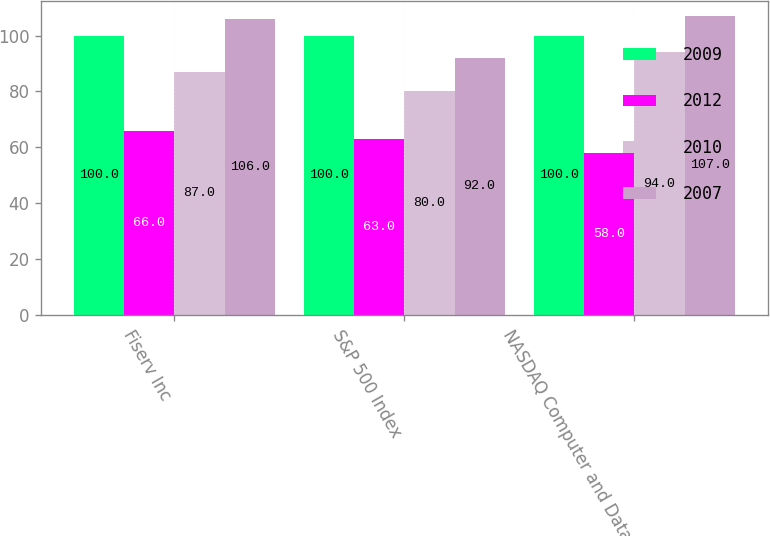Convert chart to OTSL. <chart><loc_0><loc_0><loc_500><loc_500><stacked_bar_chart><ecel><fcel>Fiserv Inc<fcel>S&P 500 Index<fcel>NASDAQ Computer and Data<nl><fcel>2009<fcel>100<fcel>100<fcel>100<nl><fcel>2012<fcel>66<fcel>63<fcel>58<nl><fcel>2010<fcel>87<fcel>80<fcel>94<nl><fcel>2007<fcel>106<fcel>92<fcel>107<nl></chart> 